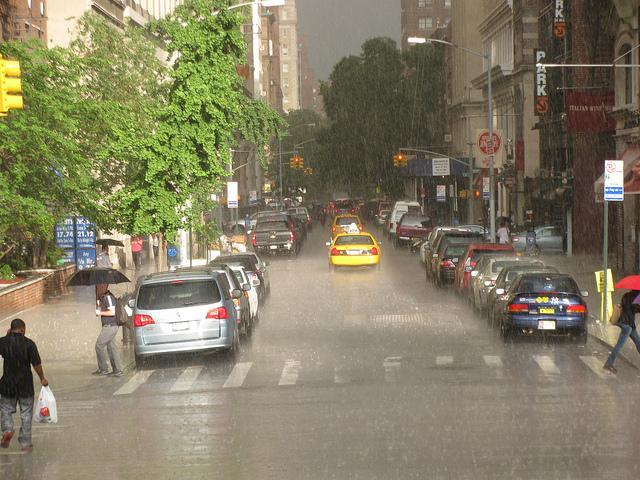What type markings are shown here? Please explain your reasoning. cross walk. The white lines indicate a crosswalk. 